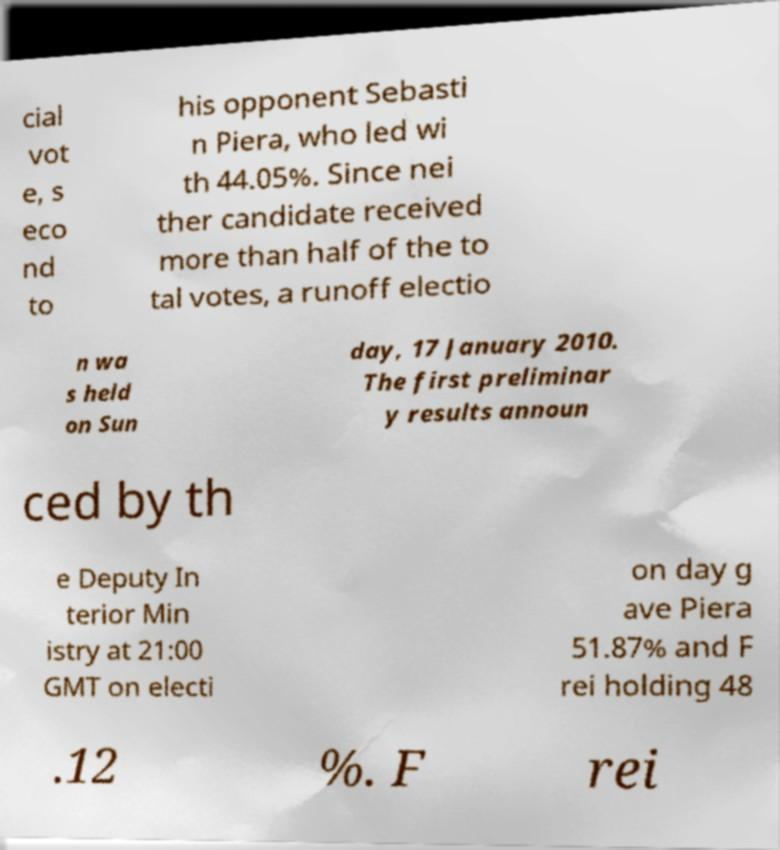For documentation purposes, I need the text within this image transcribed. Could you provide that? cial vot e, s eco nd to his opponent Sebasti n Piera, who led wi th 44.05%. Since nei ther candidate received more than half of the to tal votes, a runoff electio n wa s held on Sun day, 17 January 2010. The first preliminar y results announ ced by th e Deputy In terior Min istry at 21:00 GMT on electi on day g ave Piera 51.87% and F rei holding 48 .12 %. F rei 